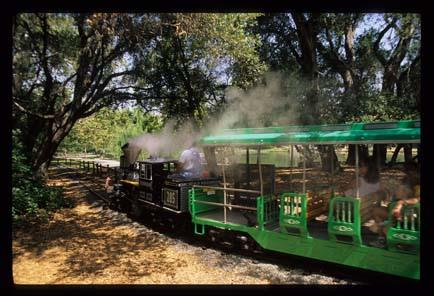What food is the same color as the largest portion of this vehicle? apple 